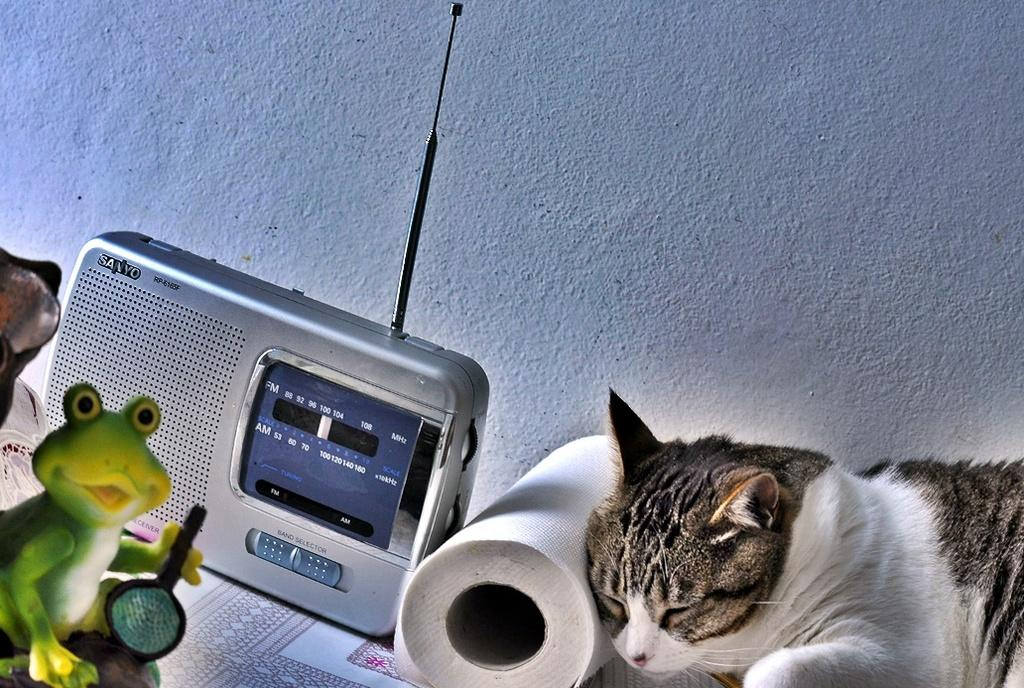What type of animal can be seen in the image? There is a cat in the image. What electronic device is present in the image? There is a radio in the image. What type of plaything is visible in the image? There is a toy in the image. Can you describe the background of the image? There is a wall in the background of the image. How many objects can be identified in the image? There are at least four objects: a cat, a radio, a toy, and other objects. What is the price of the dirt visible in the image? There is no dirt visible in the image, so it is not possible to determine its price. 